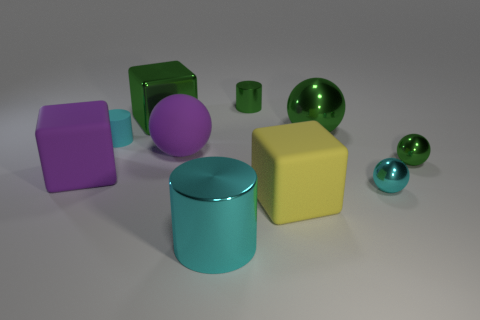Subtract all cylinders. How many objects are left? 7 Subtract all small cyan rubber cylinders. Subtract all cylinders. How many objects are left? 6 Add 6 large purple spheres. How many large purple spheres are left? 7 Add 7 purple matte balls. How many purple matte balls exist? 8 Subtract 2 cyan cylinders. How many objects are left? 8 